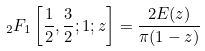<formula> <loc_0><loc_0><loc_500><loc_500>\ _ { 2 } F _ { 1 } \left [ \frac { 1 } { 2 } , \frac { 3 } { 2 } ; 1 ; z \right ] = \frac { 2 E ( z ) } { \pi ( 1 - z ) }</formula> 